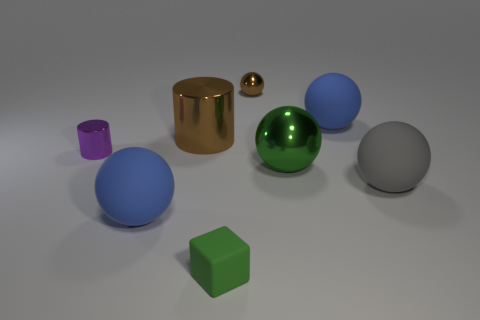Subtract all green cylinders. How many blue balls are left? 2 Subtract all blue balls. How many balls are left? 3 Subtract 3 balls. How many balls are left? 2 Subtract all brown balls. How many balls are left? 4 Subtract all purple balls. Subtract all yellow cylinders. How many balls are left? 5 Add 2 big brown shiny cylinders. How many objects exist? 10 Subtract all blocks. How many objects are left? 7 Subtract all large blue rubber objects. Subtract all big metal cylinders. How many objects are left? 5 Add 8 small brown metal things. How many small brown metal things are left? 9 Add 8 small blue cylinders. How many small blue cylinders exist? 8 